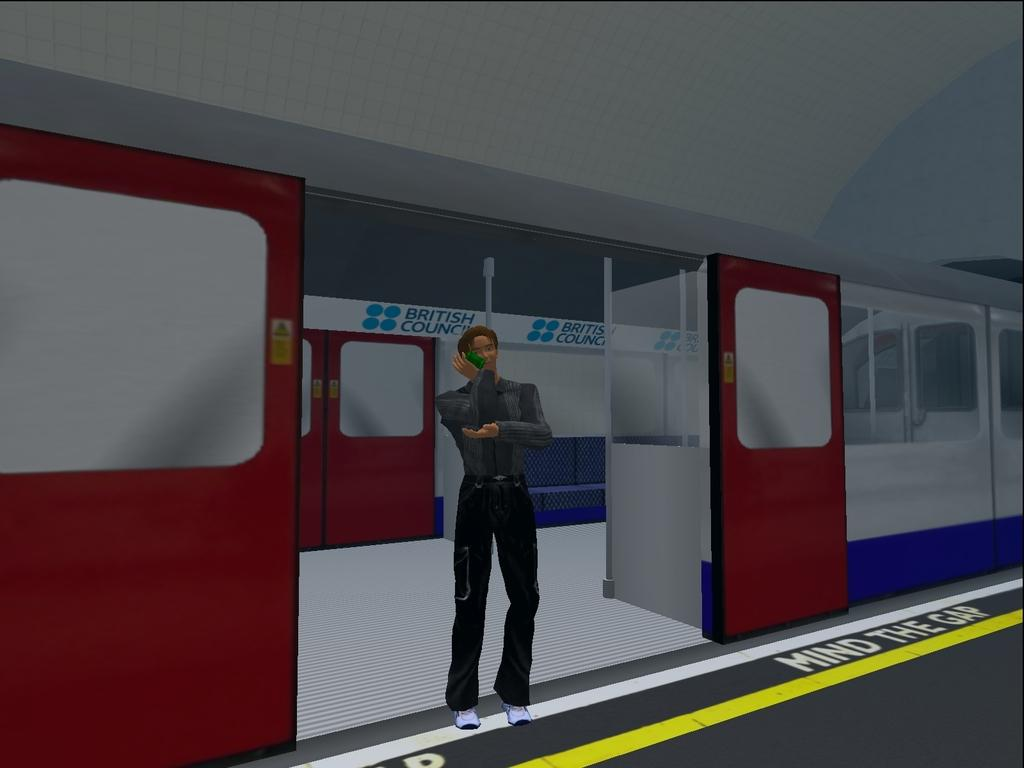What is the main subject in the center of the image? There is a poster in the center of the image. What is depicted on the poster? The poster features a train and a man. What color is the vest worn by the man in the image? There is no vest worn by the man in the image; he is depicted on a poster featuring a train. 